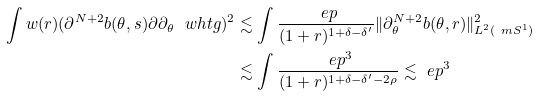<formula> <loc_0><loc_0><loc_500><loc_500>\int w ( r ) ( \partial ^ { N + 2 } b ( \theta , s ) \partial \partial _ { \theta } \ w h t g ) ^ { 2 } & \lesssim \int \frac { \ e p } { ( 1 + r ) ^ { 1 + \delta - \delta ^ { \prime } } } \| \partial _ { \theta } ^ { N + 2 } b ( \theta , r ) \| ^ { 2 } _ { L ^ { 2 } ( \ m S ^ { 1 } ) } \\ & \lesssim \int \frac { \ e p ^ { 3 } } { ( 1 + r ) ^ { 1 + \delta - \delta ^ { \prime } - 2 \rho } } \lesssim \ e p ^ { 3 }</formula> 